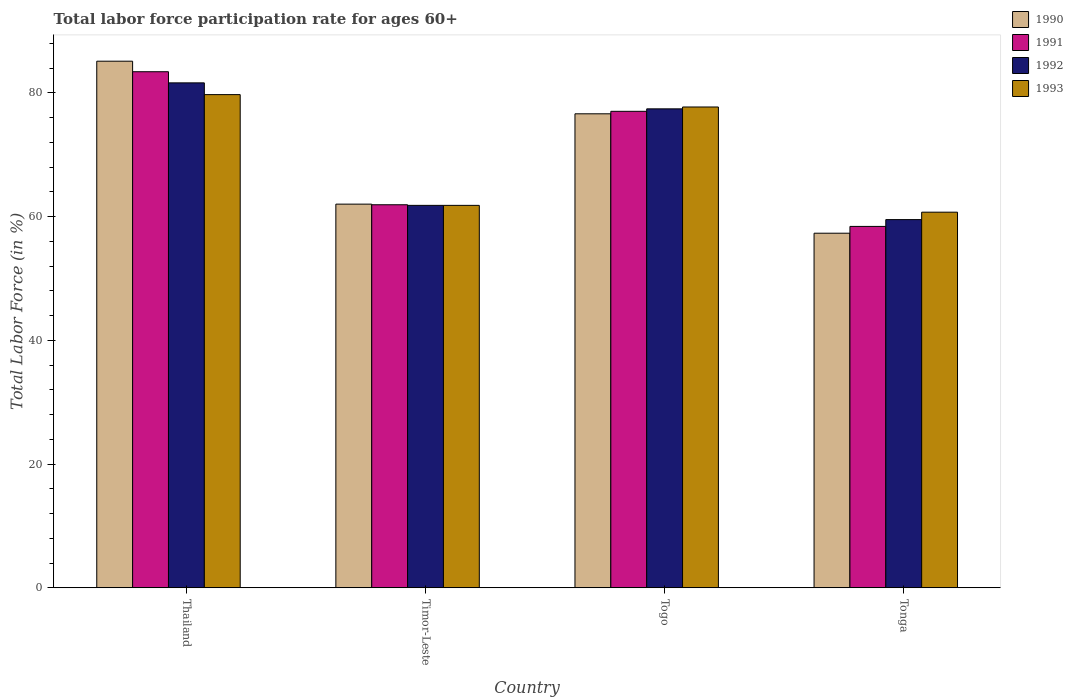How many groups of bars are there?
Your response must be concise. 4. Are the number of bars on each tick of the X-axis equal?
Your answer should be compact. Yes. How many bars are there on the 3rd tick from the right?
Make the answer very short. 4. What is the label of the 4th group of bars from the left?
Provide a succinct answer. Tonga. In how many cases, is the number of bars for a given country not equal to the number of legend labels?
Give a very brief answer. 0. What is the labor force participation rate in 1991 in Togo?
Your answer should be compact. 77. Across all countries, what is the maximum labor force participation rate in 1993?
Provide a succinct answer. 79.7. Across all countries, what is the minimum labor force participation rate in 1993?
Offer a terse response. 60.7. In which country was the labor force participation rate in 1991 maximum?
Offer a very short reply. Thailand. In which country was the labor force participation rate in 1993 minimum?
Offer a very short reply. Tonga. What is the total labor force participation rate in 1992 in the graph?
Your answer should be compact. 280.3. What is the difference between the labor force participation rate in 1991 in Thailand and that in Timor-Leste?
Keep it short and to the point. 21.5. What is the difference between the labor force participation rate in 1991 in Togo and the labor force participation rate in 1990 in Tonga?
Your answer should be compact. 19.7. What is the average labor force participation rate in 1992 per country?
Offer a terse response. 70.07. What is the difference between the labor force participation rate of/in 1992 and labor force participation rate of/in 1991 in Timor-Leste?
Offer a terse response. -0.1. What is the ratio of the labor force participation rate in 1992 in Thailand to that in Tonga?
Your response must be concise. 1.37. What is the difference between the highest and the second highest labor force participation rate in 1993?
Provide a succinct answer. -15.9. What is the difference between the highest and the lowest labor force participation rate in 1992?
Your answer should be compact. 22.1. What does the 2nd bar from the left in Togo represents?
Provide a short and direct response. 1991. Is it the case that in every country, the sum of the labor force participation rate in 1990 and labor force participation rate in 1992 is greater than the labor force participation rate in 1993?
Keep it short and to the point. Yes. What is the difference between two consecutive major ticks on the Y-axis?
Provide a succinct answer. 20. Are the values on the major ticks of Y-axis written in scientific E-notation?
Ensure brevity in your answer.  No. Does the graph contain grids?
Ensure brevity in your answer.  No. How many legend labels are there?
Offer a very short reply. 4. How are the legend labels stacked?
Offer a terse response. Vertical. What is the title of the graph?
Provide a short and direct response. Total labor force participation rate for ages 60+. What is the label or title of the X-axis?
Give a very brief answer. Country. What is the Total Labor Force (in %) in 1990 in Thailand?
Ensure brevity in your answer.  85.1. What is the Total Labor Force (in %) in 1991 in Thailand?
Give a very brief answer. 83.4. What is the Total Labor Force (in %) of 1992 in Thailand?
Make the answer very short. 81.6. What is the Total Labor Force (in %) of 1993 in Thailand?
Make the answer very short. 79.7. What is the Total Labor Force (in %) of 1991 in Timor-Leste?
Provide a short and direct response. 61.9. What is the Total Labor Force (in %) in 1992 in Timor-Leste?
Offer a very short reply. 61.8. What is the Total Labor Force (in %) of 1993 in Timor-Leste?
Ensure brevity in your answer.  61.8. What is the Total Labor Force (in %) in 1990 in Togo?
Provide a succinct answer. 76.6. What is the Total Labor Force (in %) in 1992 in Togo?
Give a very brief answer. 77.4. What is the Total Labor Force (in %) in 1993 in Togo?
Give a very brief answer. 77.7. What is the Total Labor Force (in %) in 1990 in Tonga?
Offer a very short reply. 57.3. What is the Total Labor Force (in %) in 1991 in Tonga?
Offer a terse response. 58.4. What is the Total Labor Force (in %) in 1992 in Tonga?
Give a very brief answer. 59.5. What is the Total Labor Force (in %) of 1993 in Tonga?
Ensure brevity in your answer.  60.7. Across all countries, what is the maximum Total Labor Force (in %) in 1990?
Ensure brevity in your answer.  85.1. Across all countries, what is the maximum Total Labor Force (in %) in 1991?
Your answer should be very brief. 83.4. Across all countries, what is the maximum Total Labor Force (in %) in 1992?
Offer a terse response. 81.6. Across all countries, what is the maximum Total Labor Force (in %) of 1993?
Keep it short and to the point. 79.7. Across all countries, what is the minimum Total Labor Force (in %) of 1990?
Provide a short and direct response. 57.3. Across all countries, what is the minimum Total Labor Force (in %) in 1991?
Your answer should be very brief. 58.4. Across all countries, what is the minimum Total Labor Force (in %) in 1992?
Offer a terse response. 59.5. Across all countries, what is the minimum Total Labor Force (in %) of 1993?
Your answer should be very brief. 60.7. What is the total Total Labor Force (in %) of 1990 in the graph?
Make the answer very short. 281. What is the total Total Labor Force (in %) in 1991 in the graph?
Provide a succinct answer. 280.7. What is the total Total Labor Force (in %) in 1992 in the graph?
Offer a terse response. 280.3. What is the total Total Labor Force (in %) of 1993 in the graph?
Offer a very short reply. 279.9. What is the difference between the Total Labor Force (in %) of 1990 in Thailand and that in Timor-Leste?
Offer a terse response. 23.1. What is the difference between the Total Labor Force (in %) in 1992 in Thailand and that in Timor-Leste?
Ensure brevity in your answer.  19.8. What is the difference between the Total Labor Force (in %) in 1993 in Thailand and that in Timor-Leste?
Give a very brief answer. 17.9. What is the difference between the Total Labor Force (in %) in 1991 in Thailand and that in Togo?
Give a very brief answer. 6.4. What is the difference between the Total Labor Force (in %) in 1992 in Thailand and that in Togo?
Give a very brief answer. 4.2. What is the difference between the Total Labor Force (in %) of 1993 in Thailand and that in Togo?
Your answer should be compact. 2. What is the difference between the Total Labor Force (in %) of 1990 in Thailand and that in Tonga?
Ensure brevity in your answer.  27.8. What is the difference between the Total Labor Force (in %) of 1991 in Thailand and that in Tonga?
Your answer should be very brief. 25. What is the difference between the Total Labor Force (in %) of 1992 in Thailand and that in Tonga?
Offer a terse response. 22.1. What is the difference between the Total Labor Force (in %) of 1990 in Timor-Leste and that in Togo?
Offer a terse response. -14.6. What is the difference between the Total Labor Force (in %) of 1991 in Timor-Leste and that in Togo?
Give a very brief answer. -15.1. What is the difference between the Total Labor Force (in %) of 1992 in Timor-Leste and that in Togo?
Offer a very short reply. -15.6. What is the difference between the Total Labor Force (in %) in 1993 in Timor-Leste and that in Togo?
Provide a succinct answer. -15.9. What is the difference between the Total Labor Force (in %) of 1992 in Timor-Leste and that in Tonga?
Your response must be concise. 2.3. What is the difference between the Total Labor Force (in %) of 1990 in Togo and that in Tonga?
Offer a very short reply. 19.3. What is the difference between the Total Labor Force (in %) of 1991 in Togo and that in Tonga?
Offer a terse response. 18.6. What is the difference between the Total Labor Force (in %) in 1990 in Thailand and the Total Labor Force (in %) in 1991 in Timor-Leste?
Offer a very short reply. 23.2. What is the difference between the Total Labor Force (in %) in 1990 in Thailand and the Total Labor Force (in %) in 1992 in Timor-Leste?
Offer a very short reply. 23.3. What is the difference between the Total Labor Force (in %) of 1990 in Thailand and the Total Labor Force (in %) of 1993 in Timor-Leste?
Your response must be concise. 23.3. What is the difference between the Total Labor Force (in %) in 1991 in Thailand and the Total Labor Force (in %) in 1992 in Timor-Leste?
Make the answer very short. 21.6. What is the difference between the Total Labor Force (in %) in 1991 in Thailand and the Total Labor Force (in %) in 1993 in Timor-Leste?
Keep it short and to the point. 21.6. What is the difference between the Total Labor Force (in %) of 1992 in Thailand and the Total Labor Force (in %) of 1993 in Timor-Leste?
Provide a short and direct response. 19.8. What is the difference between the Total Labor Force (in %) of 1990 in Thailand and the Total Labor Force (in %) of 1991 in Togo?
Keep it short and to the point. 8.1. What is the difference between the Total Labor Force (in %) in 1990 in Thailand and the Total Labor Force (in %) in 1993 in Togo?
Your answer should be very brief. 7.4. What is the difference between the Total Labor Force (in %) in 1990 in Thailand and the Total Labor Force (in %) in 1991 in Tonga?
Your response must be concise. 26.7. What is the difference between the Total Labor Force (in %) of 1990 in Thailand and the Total Labor Force (in %) of 1992 in Tonga?
Keep it short and to the point. 25.6. What is the difference between the Total Labor Force (in %) in 1990 in Thailand and the Total Labor Force (in %) in 1993 in Tonga?
Offer a terse response. 24.4. What is the difference between the Total Labor Force (in %) in 1991 in Thailand and the Total Labor Force (in %) in 1992 in Tonga?
Your response must be concise. 23.9. What is the difference between the Total Labor Force (in %) of 1991 in Thailand and the Total Labor Force (in %) of 1993 in Tonga?
Make the answer very short. 22.7. What is the difference between the Total Labor Force (in %) in 1992 in Thailand and the Total Labor Force (in %) in 1993 in Tonga?
Your response must be concise. 20.9. What is the difference between the Total Labor Force (in %) in 1990 in Timor-Leste and the Total Labor Force (in %) in 1991 in Togo?
Offer a very short reply. -15. What is the difference between the Total Labor Force (in %) in 1990 in Timor-Leste and the Total Labor Force (in %) in 1992 in Togo?
Your answer should be very brief. -15.4. What is the difference between the Total Labor Force (in %) of 1990 in Timor-Leste and the Total Labor Force (in %) of 1993 in Togo?
Give a very brief answer. -15.7. What is the difference between the Total Labor Force (in %) of 1991 in Timor-Leste and the Total Labor Force (in %) of 1992 in Togo?
Your answer should be compact. -15.5. What is the difference between the Total Labor Force (in %) in 1991 in Timor-Leste and the Total Labor Force (in %) in 1993 in Togo?
Make the answer very short. -15.8. What is the difference between the Total Labor Force (in %) in 1992 in Timor-Leste and the Total Labor Force (in %) in 1993 in Togo?
Ensure brevity in your answer.  -15.9. What is the difference between the Total Labor Force (in %) in 1990 in Timor-Leste and the Total Labor Force (in %) in 1991 in Tonga?
Ensure brevity in your answer.  3.6. What is the difference between the Total Labor Force (in %) in 1990 in Timor-Leste and the Total Labor Force (in %) in 1992 in Tonga?
Offer a very short reply. 2.5. What is the difference between the Total Labor Force (in %) in 1990 in Togo and the Total Labor Force (in %) in 1992 in Tonga?
Your answer should be very brief. 17.1. What is the difference between the Total Labor Force (in %) of 1991 in Togo and the Total Labor Force (in %) of 1992 in Tonga?
Your answer should be very brief. 17.5. What is the difference between the Total Labor Force (in %) of 1991 in Togo and the Total Labor Force (in %) of 1993 in Tonga?
Ensure brevity in your answer.  16.3. What is the average Total Labor Force (in %) in 1990 per country?
Keep it short and to the point. 70.25. What is the average Total Labor Force (in %) in 1991 per country?
Make the answer very short. 70.17. What is the average Total Labor Force (in %) of 1992 per country?
Make the answer very short. 70.08. What is the average Total Labor Force (in %) of 1993 per country?
Keep it short and to the point. 69.97. What is the difference between the Total Labor Force (in %) of 1990 and Total Labor Force (in %) of 1991 in Thailand?
Make the answer very short. 1.7. What is the difference between the Total Labor Force (in %) in 1990 and Total Labor Force (in %) in 1992 in Thailand?
Keep it short and to the point. 3.5. What is the difference between the Total Labor Force (in %) in 1990 and Total Labor Force (in %) in 1993 in Thailand?
Your answer should be compact. 5.4. What is the difference between the Total Labor Force (in %) of 1991 and Total Labor Force (in %) of 1992 in Thailand?
Provide a short and direct response. 1.8. What is the difference between the Total Labor Force (in %) of 1990 and Total Labor Force (in %) of 1991 in Timor-Leste?
Provide a succinct answer. 0.1. What is the difference between the Total Labor Force (in %) in 1990 and Total Labor Force (in %) in 1993 in Timor-Leste?
Your response must be concise. 0.2. What is the difference between the Total Labor Force (in %) in 1991 and Total Labor Force (in %) in 1992 in Timor-Leste?
Your answer should be very brief. 0.1. What is the difference between the Total Labor Force (in %) in 1992 and Total Labor Force (in %) in 1993 in Timor-Leste?
Offer a terse response. 0. What is the difference between the Total Labor Force (in %) of 1991 and Total Labor Force (in %) of 1992 in Togo?
Offer a terse response. -0.4. What is the difference between the Total Labor Force (in %) in 1991 and Total Labor Force (in %) in 1993 in Togo?
Offer a very short reply. -0.7. What is the difference between the Total Labor Force (in %) in 1991 and Total Labor Force (in %) in 1993 in Tonga?
Your answer should be very brief. -2.3. What is the ratio of the Total Labor Force (in %) of 1990 in Thailand to that in Timor-Leste?
Your response must be concise. 1.37. What is the ratio of the Total Labor Force (in %) of 1991 in Thailand to that in Timor-Leste?
Your response must be concise. 1.35. What is the ratio of the Total Labor Force (in %) in 1992 in Thailand to that in Timor-Leste?
Provide a short and direct response. 1.32. What is the ratio of the Total Labor Force (in %) in 1993 in Thailand to that in Timor-Leste?
Make the answer very short. 1.29. What is the ratio of the Total Labor Force (in %) of 1990 in Thailand to that in Togo?
Ensure brevity in your answer.  1.11. What is the ratio of the Total Labor Force (in %) of 1991 in Thailand to that in Togo?
Your answer should be compact. 1.08. What is the ratio of the Total Labor Force (in %) in 1992 in Thailand to that in Togo?
Offer a very short reply. 1.05. What is the ratio of the Total Labor Force (in %) in 1993 in Thailand to that in Togo?
Offer a very short reply. 1.03. What is the ratio of the Total Labor Force (in %) in 1990 in Thailand to that in Tonga?
Offer a very short reply. 1.49. What is the ratio of the Total Labor Force (in %) in 1991 in Thailand to that in Tonga?
Your answer should be compact. 1.43. What is the ratio of the Total Labor Force (in %) in 1992 in Thailand to that in Tonga?
Provide a succinct answer. 1.37. What is the ratio of the Total Labor Force (in %) in 1993 in Thailand to that in Tonga?
Your answer should be compact. 1.31. What is the ratio of the Total Labor Force (in %) of 1990 in Timor-Leste to that in Togo?
Provide a succinct answer. 0.81. What is the ratio of the Total Labor Force (in %) of 1991 in Timor-Leste to that in Togo?
Your answer should be compact. 0.8. What is the ratio of the Total Labor Force (in %) of 1992 in Timor-Leste to that in Togo?
Provide a short and direct response. 0.8. What is the ratio of the Total Labor Force (in %) in 1993 in Timor-Leste to that in Togo?
Offer a very short reply. 0.8. What is the ratio of the Total Labor Force (in %) in 1990 in Timor-Leste to that in Tonga?
Your response must be concise. 1.08. What is the ratio of the Total Labor Force (in %) in 1991 in Timor-Leste to that in Tonga?
Give a very brief answer. 1.06. What is the ratio of the Total Labor Force (in %) of 1992 in Timor-Leste to that in Tonga?
Give a very brief answer. 1.04. What is the ratio of the Total Labor Force (in %) of 1993 in Timor-Leste to that in Tonga?
Give a very brief answer. 1.02. What is the ratio of the Total Labor Force (in %) in 1990 in Togo to that in Tonga?
Your answer should be very brief. 1.34. What is the ratio of the Total Labor Force (in %) in 1991 in Togo to that in Tonga?
Your response must be concise. 1.32. What is the ratio of the Total Labor Force (in %) in 1992 in Togo to that in Tonga?
Provide a succinct answer. 1.3. What is the ratio of the Total Labor Force (in %) of 1993 in Togo to that in Tonga?
Give a very brief answer. 1.28. What is the difference between the highest and the second highest Total Labor Force (in %) of 1991?
Provide a short and direct response. 6.4. What is the difference between the highest and the second highest Total Labor Force (in %) in 1992?
Give a very brief answer. 4.2. What is the difference between the highest and the lowest Total Labor Force (in %) in 1990?
Your answer should be very brief. 27.8. What is the difference between the highest and the lowest Total Labor Force (in %) of 1991?
Make the answer very short. 25. What is the difference between the highest and the lowest Total Labor Force (in %) of 1992?
Offer a very short reply. 22.1. What is the difference between the highest and the lowest Total Labor Force (in %) of 1993?
Keep it short and to the point. 19. 